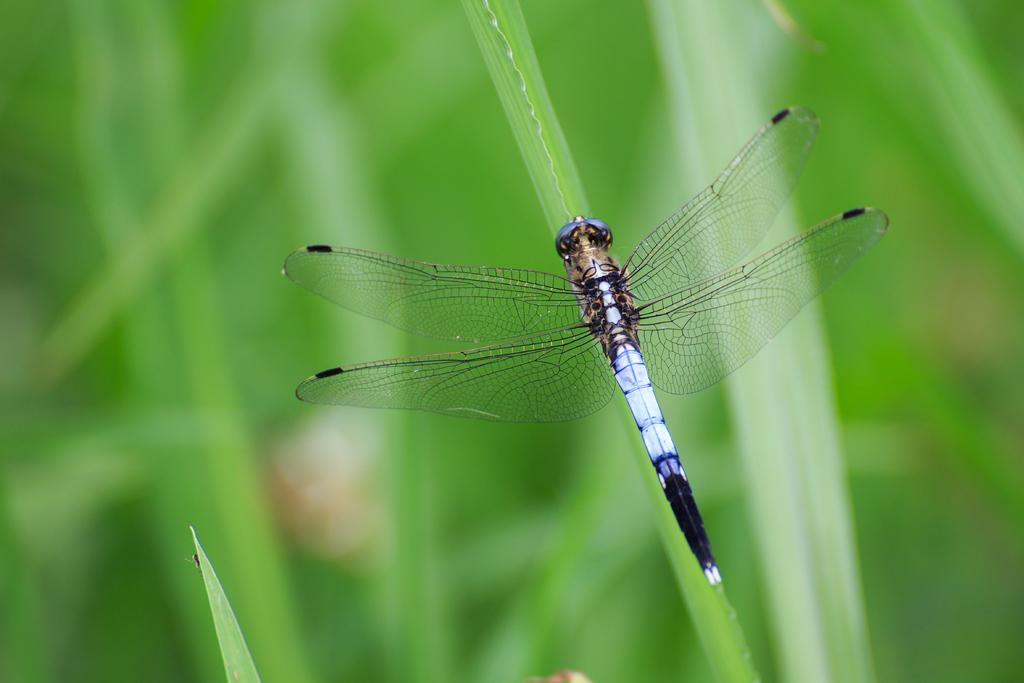What insect is on the leaf in the image? There is a dragonfly on a leaf in the image. What can be seen in the background of the image? There are plants visible in the background of the image. How would you describe the clarity of the image? The image is blurry. What type of shoes is the dragonfly wearing in the image? There are no shoes present in the image, as dragonflies do not wear shoes. 